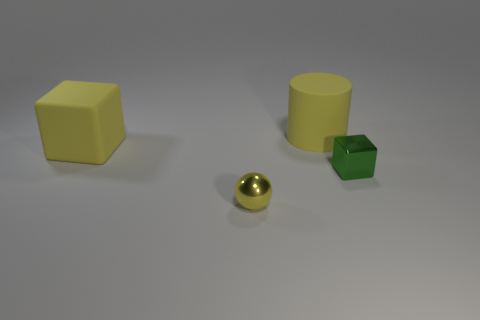Add 2 yellow blocks. How many objects exist? 6 Subtract all balls. How many objects are left? 3 Add 1 cylinders. How many cylinders are left? 2 Add 2 blocks. How many blocks exist? 4 Subtract 0 purple cylinders. How many objects are left? 4 Subtract all yellow metal spheres. Subtract all yellow metallic balls. How many objects are left? 2 